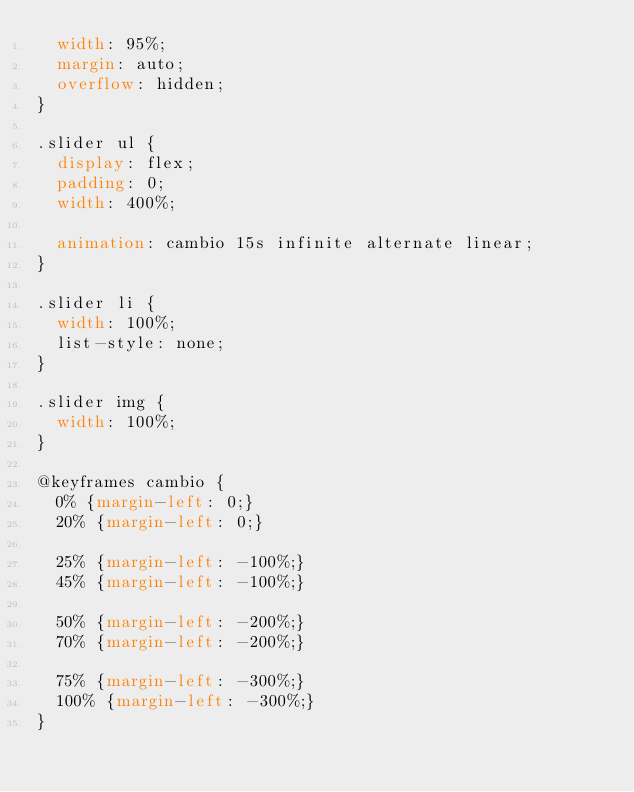Convert code to text. <code><loc_0><loc_0><loc_500><loc_500><_CSS_>	width: 95%;
	margin: auto;
	overflow: hidden;
}

.slider ul {
	display: flex;
	padding: 0;
	width: 400%;
	
	animation: cambio 15s infinite alternate linear;
}

.slider li {
	width: 100%;
	list-style: none;
}

.slider img {
	width: 100%;
}

@keyframes cambio {
	0% {margin-left: 0;}
	20% {margin-left: 0;}
	
	25% {margin-left: -100%;}
	45% {margin-left: -100%;}
	
	50% {margin-left: -200%;}
	70% {margin-left: -200%;}
	
	75% {margin-left: -300%;}
	100% {margin-left: -300%;}
}
</code> 